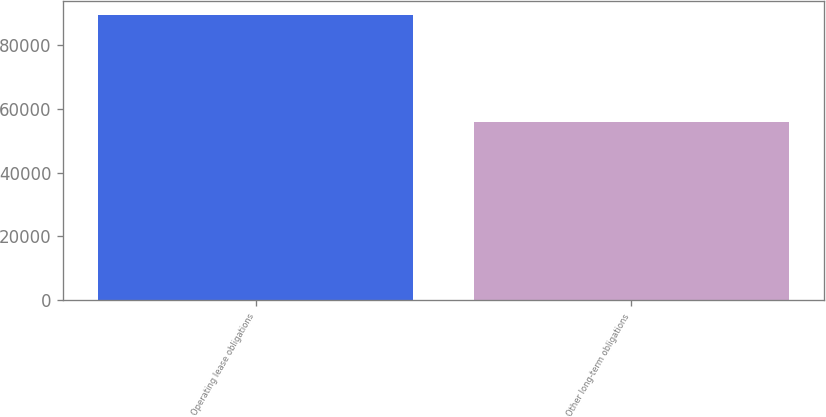<chart> <loc_0><loc_0><loc_500><loc_500><bar_chart><fcel>Operating lease obligations<fcel>Other long-term obligations<nl><fcel>89186<fcel>55889<nl></chart> 